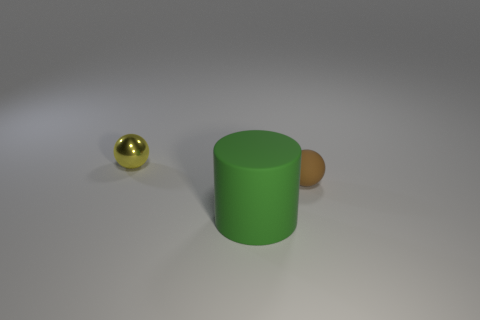Is there any other thing that has the same material as the yellow object?
Offer a very short reply. No. What color is the other tiny object that is the same shape as the small yellow metal object?
Make the answer very short. Brown. Is the yellow ball the same size as the brown matte ball?
Ensure brevity in your answer.  Yes. What is the material of the yellow thing?
Offer a very short reply. Metal. There is a small thing that is made of the same material as the large green cylinder; what is its color?
Offer a terse response. Brown. Is the material of the green object the same as the ball that is on the right side of the cylinder?
Offer a very short reply. Yes. How many green cylinders are made of the same material as the yellow thing?
Offer a terse response. 0. What shape is the tiny thing that is left of the brown ball?
Provide a short and direct response. Sphere. Do the small thing that is right of the large green rubber thing and the small thing that is left of the tiny matte ball have the same material?
Make the answer very short. No. Is there another tiny object that has the same shape as the brown rubber thing?
Offer a very short reply. Yes. 